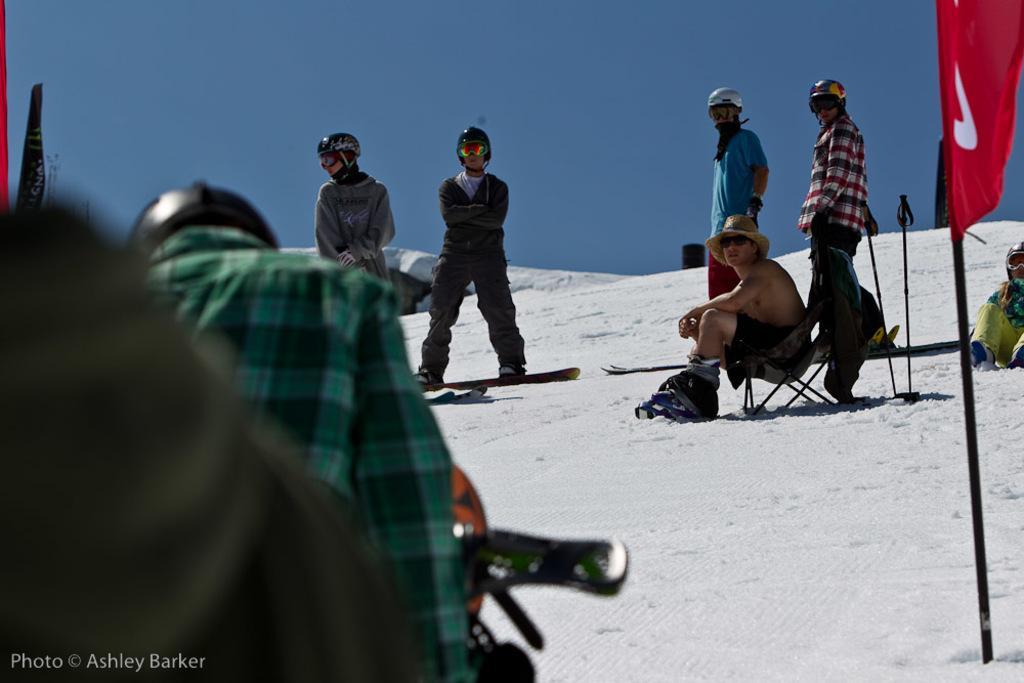How would you summarize this image in a sentence or two? There are few people here wearing helmets,glasses and standing on the skate board and a person is sitting on the chair,another person is on a vehicle. This is snow and a flag here. In the background it is sky. 